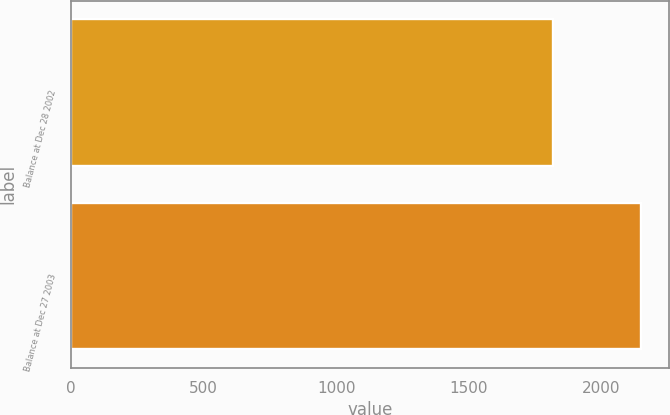Convert chart. <chart><loc_0><loc_0><loc_500><loc_500><bar_chart><fcel>Balance at Dec 28 2002<fcel>Balance at Dec 27 2003<nl><fcel>1817<fcel>2148<nl></chart> 